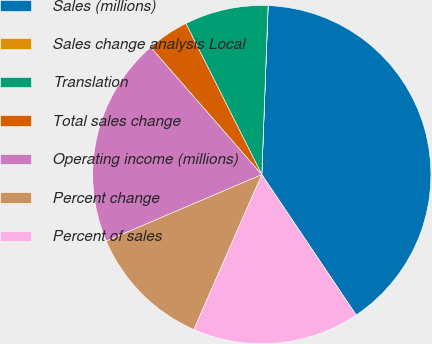Convert chart to OTSL. <chart><loc_0><loc_0><loc_500><loc_500><pie_chart><fcel>Sales (millions)<fcel>Sales change analysis Local<fcel>Translation<fcel>Total sales change<fcel>Operating income (millions)<fcel>Percent change<fcel>Percent of sales<nl><fcel>39.98%<fcel>0.01%<fcel>8.0%<fcel>4.01%<fcel>20.0%<fcel>12.0%<fcel>16.0%<nl></chart> 